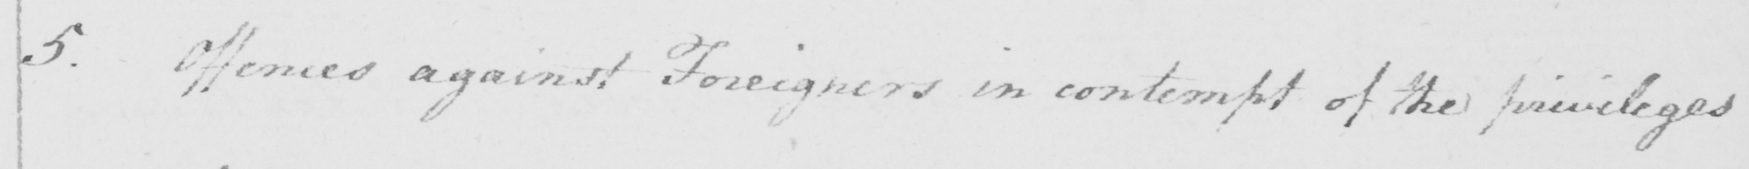What is written in this line of handwriting? 5 . Offences against Foreigners in contempt of the privileges 